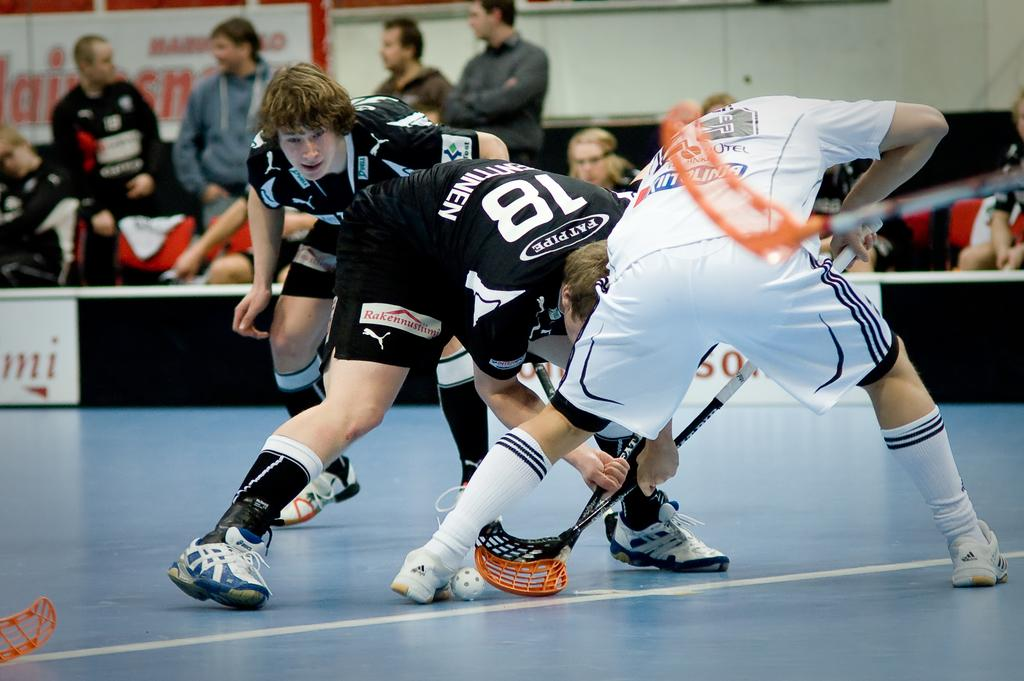<image>
Give a short and clear explanation of the subsequent image. Three Lacrosse players playing indoors, one of whom is Pat Pipe #18. 